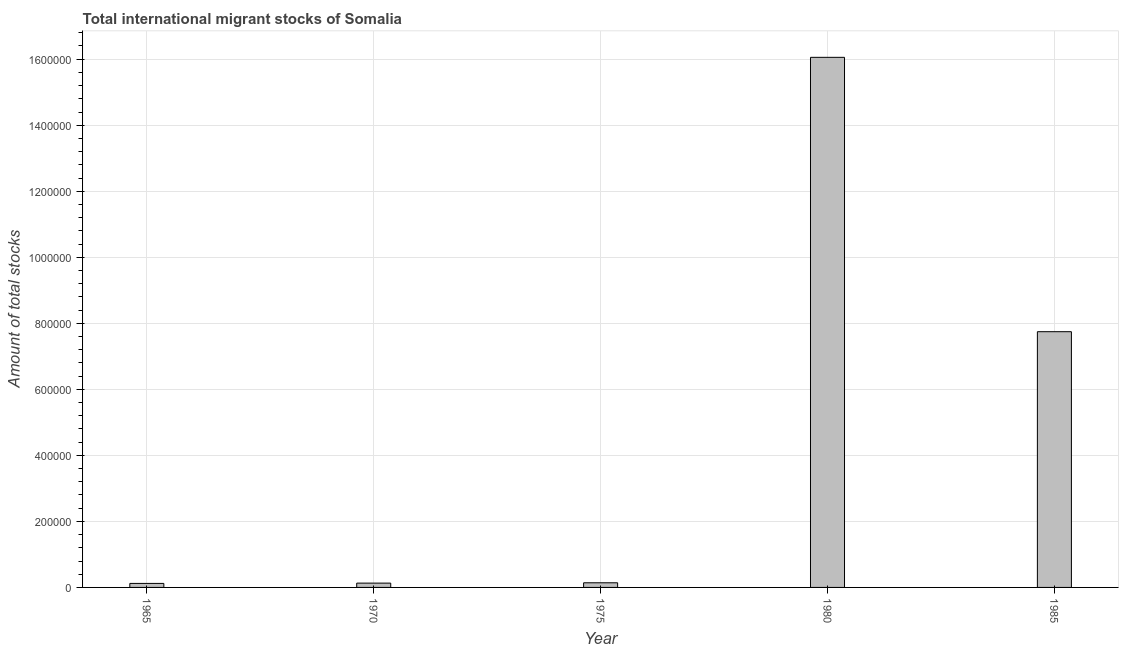Does the graph contain any zero values?
Make the answer very short. No. Does the graph contain grids?
Offer a very short reply. Yes. What is the title of the graph?
Your answer should be compact. Total international migrant stocks of Somalia. What is the label or title of the Y-axis?
Offer a terse response. Amount of total stocks. What is the total number of international migrant stock in 1975?
Your answer should be very brief. 1.40e+04. Across all years, what is the maximum total number of international migrant stock?
Keep it short and to the point. 1.61e+06. Across all years, what is the minimum total number of international migrant stock?
Ensure brevity in your answer.  1.21e+04. In which year was the total number of international migrant stock maximum?
Offer a terse response. 1980. In which year was the total number of international migrant stock minimum?
Your answer should be very brief. 1965. What is the sum of the total number of international migrant stock?
Provide a succinct answer. 2.42e+06. What is the difference between the total number of international migrant stock in 1970 and 1980?
Ensure brevity in your answer.  -1.59e+06. What is the average total number of international migrant stock per year?
Offer a very short reply. 4.84e+05. What is the median total number of international migrant stock?
Ensure brevity in your answer.  1.40e+04. Do a majority of the years between 1975 and 1985 (inclusive) have total number of international migrant stock greater than 480000 ?
Your response must be concise. Yes. What is the ratio of the total number of international migrant stock in 1975 to that in 1980?
Make the answer very short. 0.01. Is the total number of international migrant stock in 1970 less than that in 1975?
Your answer should be very brief. Yes. Is the difference between the total number of international migrant stock in 1970 and 1980 greater than the difference between any two years?
Offer a very short reply. No. What is the difference between the highest and the second highest total number of international migrant stock?
Offer a terse response. 8.31e+05. Is the sum of the total number of international migrant stock in 1970 and 1975 greater than the maximum total number of international migrant stock across all years?
Offer a terse response. No. What is the difference between the highest and the lowest total number of international migrant stock?
Make the answer very short. 1.59e+06. In how many years, is the total number of international migrant stock greater than the average total number of international migrant stock taken over all years?
Your response must be concise. 2. How many bars are there?
Provide a short and direct response. 5. How many years are there in the graph?
Ensure brevity in your answer.  5. What is the difference between two consecutive major ticks on the Y-axis?
Offer a very short reply. 2.00e+05. Are the values on the major ticks of Y-axis written in scientific E-notation?
Keep it short and to the point. No. What is the Amount of total stocks in 1965?
Offer a very short reply. 1.21e+04. What is the Amount of total stocks in 1970?
Offer a terse response. 1.30e+04. What is the Amount of total stocks in 1975?
Offer a very short reply. 1.40e+04. What is the Amount of total stocks in 1980?
Keep it short and to the point. 1.61e+06. What is the Amount of total stocks of 1985?
Give a very brief answer. 7.75e+05. What is the difference between the Amount of total stocks in 1965 and 1970?
Provide a short and direct response. -905. What is the difference between the Amount of total stocks in 1965 and 1975?
Offer a terse response. -1912. What is the difference between the Amount of total stocks in 1965 and 1980?
Give a very brief answer. -1.59e+06. What is the difference between the Amount of total stocks in 1965 and 1985?
Provide a succinct answer. -7.62e+05. What is the difference between the Amount of total stocks in 1970 and 1975?
Offer a very short reply. -1007. What is the difference between the Amount of total stocks in 1970 and 1980?
Offer a very short reply. -1.59e+06. What is the difference between the Amount of total stocks in 1970 and 1985?
Your answer should be compact. -7.62e+05. What is the difference between the Amount of total stocks in 1975 and 1980?
Offer a terse response. -1.59e+06. What is the difference between the Amount of total stocks in 1975 and 1985?
Ensure brevity in your answer.  -7.61e+05. What is the difference between the Amount of total stocks in 1980 and 1985?
Ensure brevity in your answer.  8.31e+05. What is the ratio of the Amount of total stocks in 1965 to that in 1970?
Provide a succinct answer. 0.93. What is the ratio of the Amount of total stocks in 1965 to that in 1975?
Provide a short and direct response. 0.86. What is the ratio of the Amount of total stocks in 1965 to that in 1980?
Your answer should be compact. 0.01. What is the ratio of the Amount of total stocks in 1965 to that in 1985?
Ensure brevity in your answer.  0.02. What is the ratio of the Amount of total stocks in 1970 to that in 1975?
Provide a succinct answer. 0.93. What is the ratio of the Amount of total stocks in 1970 to that in 1980?
Give a very brief answer. 0.01. What is the ratio of the Amount of total stocks in 1970 to that in 1985?
Your answer should be very brief. 0.02. What is the ratio of the Amount of total stocks in 1975 to that in 1980?
Provide a succinct answer. 0.01. What is the ratio of the Amount of total stocks in 1975 to that in 1985?
Keep it short and to the point. 0.02. What is the ratio of the Amount of total stocks in 1980 to that in 1985?
Keep it short and to the point. 2.07. 